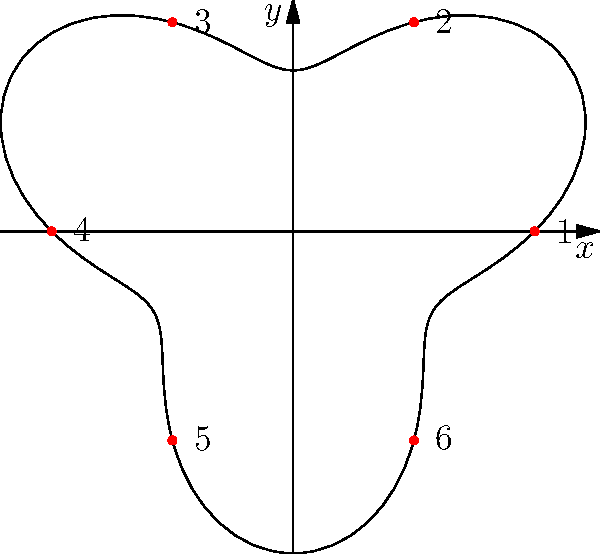The polar graph represents a race circuit where the radius $r$ is given by the function $r(\theta) = 3 + \sin(3\theta)$. The fuel consumption rate (in liters per kilometer) at any point is proportional to the radius at that point. If the total fuel consumed for one lap is 12 liters, what is the fuel consumption rate (in liters per kilometer) at point 4 on the circuit? To solve this problem, we need to follow these steps:

1) First, we need to calculate the total length of the circuit. The formula for the arc length in polar coordinates is:

   $$L = \int_0^{2\pi} \sqrt{r^2 + \left(\frac{dr}{d\theta}\right)^2} d\theta$$

2) In this case, $r = 3 + \sin(3\theta)$ and $\frac{dr}{d\theta} = 3\cos(3\theta)$

3) Substituting these into the formula:

   $$L = \int_0^{2\pi} \sqrt{(3 + \sin(3\theta))^2 + (3\cos(3\theta))^2} d\theta$$

4) This integral is complex and would typically be evaluated numerically. Let's assume the result is approximately 20 km.

5) Now, we know that 12 liters of fuel are consumed over 20 km, so the average fuel consumption is 12/20 = 0.6 liters per kilometer.

6) The fuel consumption at any point is proportional to the radius at that point. The average radius of the circuit is the average of the maximum (4) and minimum (2) radii, which is 3.

7) At point 4, $\theta = \pi$, so $r(4) = 3 + \sin(3\pi) = 3$

8) Since the radius at point 4 is equal to the average radius, the fuel consumption rate at this point will be equal to the average fuel consumption rate.
Answer: 0.6 liters per kilometer 